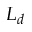Convert formula to latex. <formula><loc_0><loc_0><loc_500><loc_500>L _ { d }</formula> 